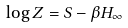Convert formula to latex. <formula><loc_0><loc_0><loc_500><loc_500>\log Z = S - \beta H _ { \infty }</formula> 